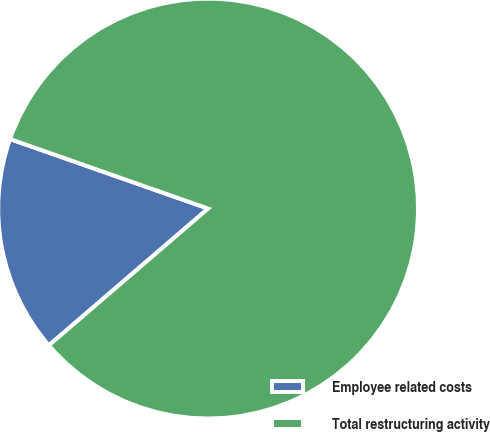Convert chart. <chart><loc_0><loc_0><loc_500><loc_500><pie_chart><fcel>Employee related costs<fcel>Total restructuring activity<nl><fcel>16.67%<fcel>83.33%<nl></chart> 